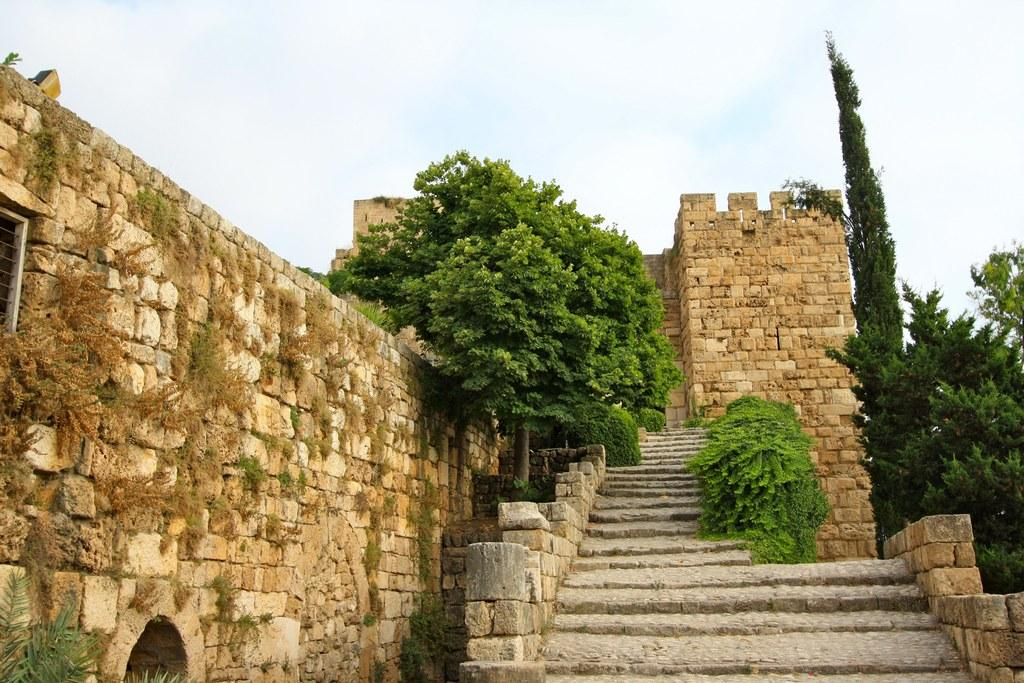What type of structure can be seen in the image? There is a wall in the image. What architectural feature is present in the image? There is a staircase in the image. What type of vegetation is visible in the image? There are trees in the image. What is visible at the top of the image? The sky is visible at the top of the image. Can you hear the ear in the image? There is no ear present in the image, so it cannot be heard. How many times does the hammer kick the wall in the image? There is no hammer or kicking action present in the image; it only features a wall, staircase, trees, and the sky. 